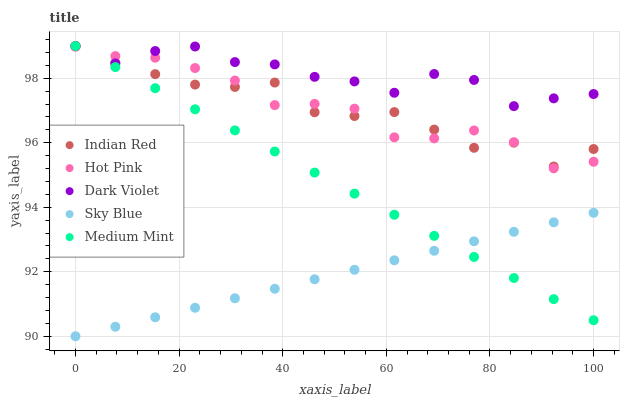Does Sky Blue have the minimum area under the curve?
Answer yes or no. Yes. Does Dark Violet have the maximum area under the curve?
Answer yes or no. Yes. Does Hot Pink have the minimum area under the curve?
Answer yes or no. No. Does Hot Pink have the maximum area under the curve?
Answer yes or no. No. Is Sky Blue the smoothest?
Answer yes or no. Yes. Is Dark Violet the roughest?
Answer yes or no. Yes. Is Hot Pink the smoothest?
Answer yes or no. No. Is Hot Pink the roughest?
Answer yes or no. No. Does Sky Blue have the lowest value?
Answer yes or no. Yes. Does Hot Pink have the lowest value?
Answer yes or no. No. Does Indian Red have the highest value?
Answer yes or no. Yes. Does Hot Pink have the highest value?
Answer yes or no. No. Is Sky Blue less than Dark Violet?
Answer yes or no. Yes. Is Indian Red greater than Sky Blue?
Answer yes or no. Yes. Does Hot Pink intersect Indian Red?
Answer yes or no. Yes. Is Hot Pink less than Indian Red?
Answer yes or no. No. Is Hot Pink greater than Indian Red?
Answer yes or no. No. Does Sky Blue intersect Dark Violet?
Answer yes or no. No. 